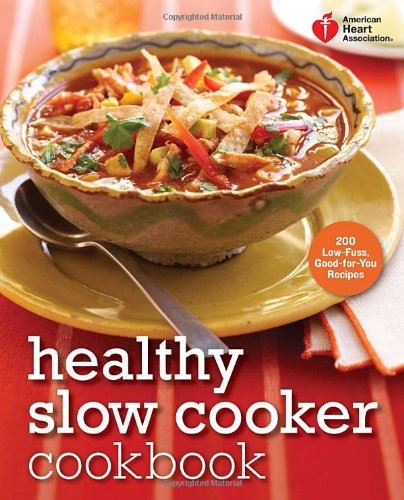Can you explain what 'Low-Fuss' means as mentioned on the cookbook cover? 'Low-Fuss' in the context of this cookbook refers to recipes that require minimal preparation and supervision. These dishes are designed to be straightforward, making them perfect for busy individuals who still wish to enjoy homemade, nutritious meals. 